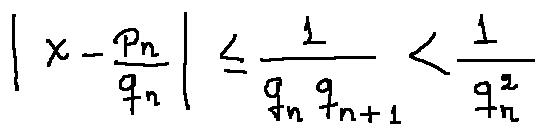Convert formula to latex. <formula><loc_0><loc_0><loc_500><loc_500>| x - \frac { p _ { n } } { q _ { n } } | \leq \frac { 1 } { q _ { n } q _ { n + 1 } } < \frac { 1 } { q _ { n } ^ { 2 } }</formula> 